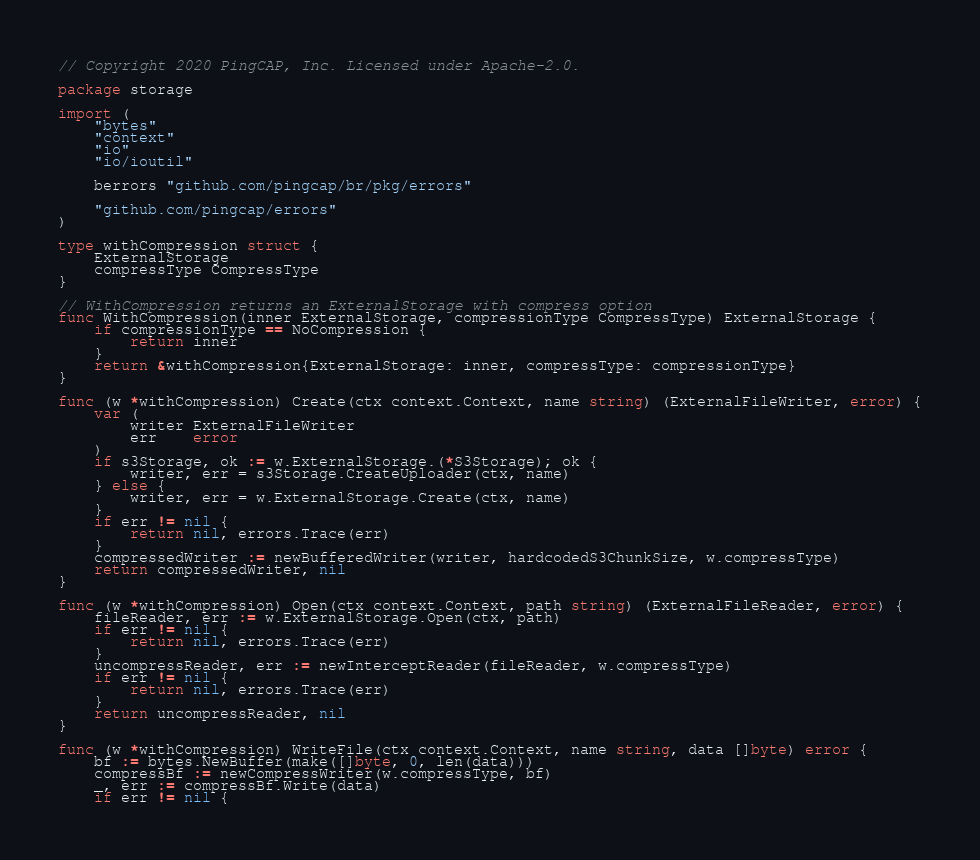Convert code to text. <code><loc_0><loc_0><loc_500><loc_500><_Go_>// Copyright 2020 PingCAP, Inc. Licensed under Apache-2.0.

package storage

import (
	"bytes"
	"context"
	"io"
	"io/ioutil"

	berrors "github.com/pingcap/br/pkg/errors"

	"github.com/pingcap/errors"
)

type withCompression struct {
	ExternalStorage
	compressType CompressType
}

// WithCompression returns an ExternalStorage with compress option
func WithCompression(inner ExternalStorage, compressionType CompressType) ExternalStorage {
	if compressionType == NoCompression {
		return inner
	}
	return &withCompression{ExternalStorage: inner, compressType: compressionType}
}

func (w *withCompression) Create(ctx context.Context, name string) (ExternalFileWriter, error) {
	var (
		writer ExternalFileWriter
		err    error
	)
	if s3Storage, ok := w.ExternalStorage.(*S3Storage); ok {
		writer, err = s3Storage.CreateUploader(ctx, name)
	} else {
		writer, err = w.ExternalStorage.Create(ctx, name)
	}
	if err != nil {
		return nil, errors.Trace(err)
	}
	compressedWriter := newBufferedWriter(writer, hardcodedS3ChunkSize, w.compressType)
	return compressedWriter, nil
}

func (w *withCompression) Open(ctx context.Context, path string) (ExternalFileReader, error) {
	fileReader, err := w.ExternalStorage.Open(ctx, path)
	if err != nil {
		return nil, errors.Trace(err)
	}
	uncompressReader, err := newInterceptReader(fileReader, w.compressType)
	if err != nil {
		return nil, errors.Trace(err)
	}
	return uncompressReader, nil
}

func (w *withCompression) WriteFile(ctx context.Context, name string, data []byte) error {
	bf := bytes.NewBuffer(make([]byte, 0, len(data)))
	compressBf := newCompressWriter(w.compressType, bf)
	_, err := compressBf.Write(data)
	if err != nil {</code> 